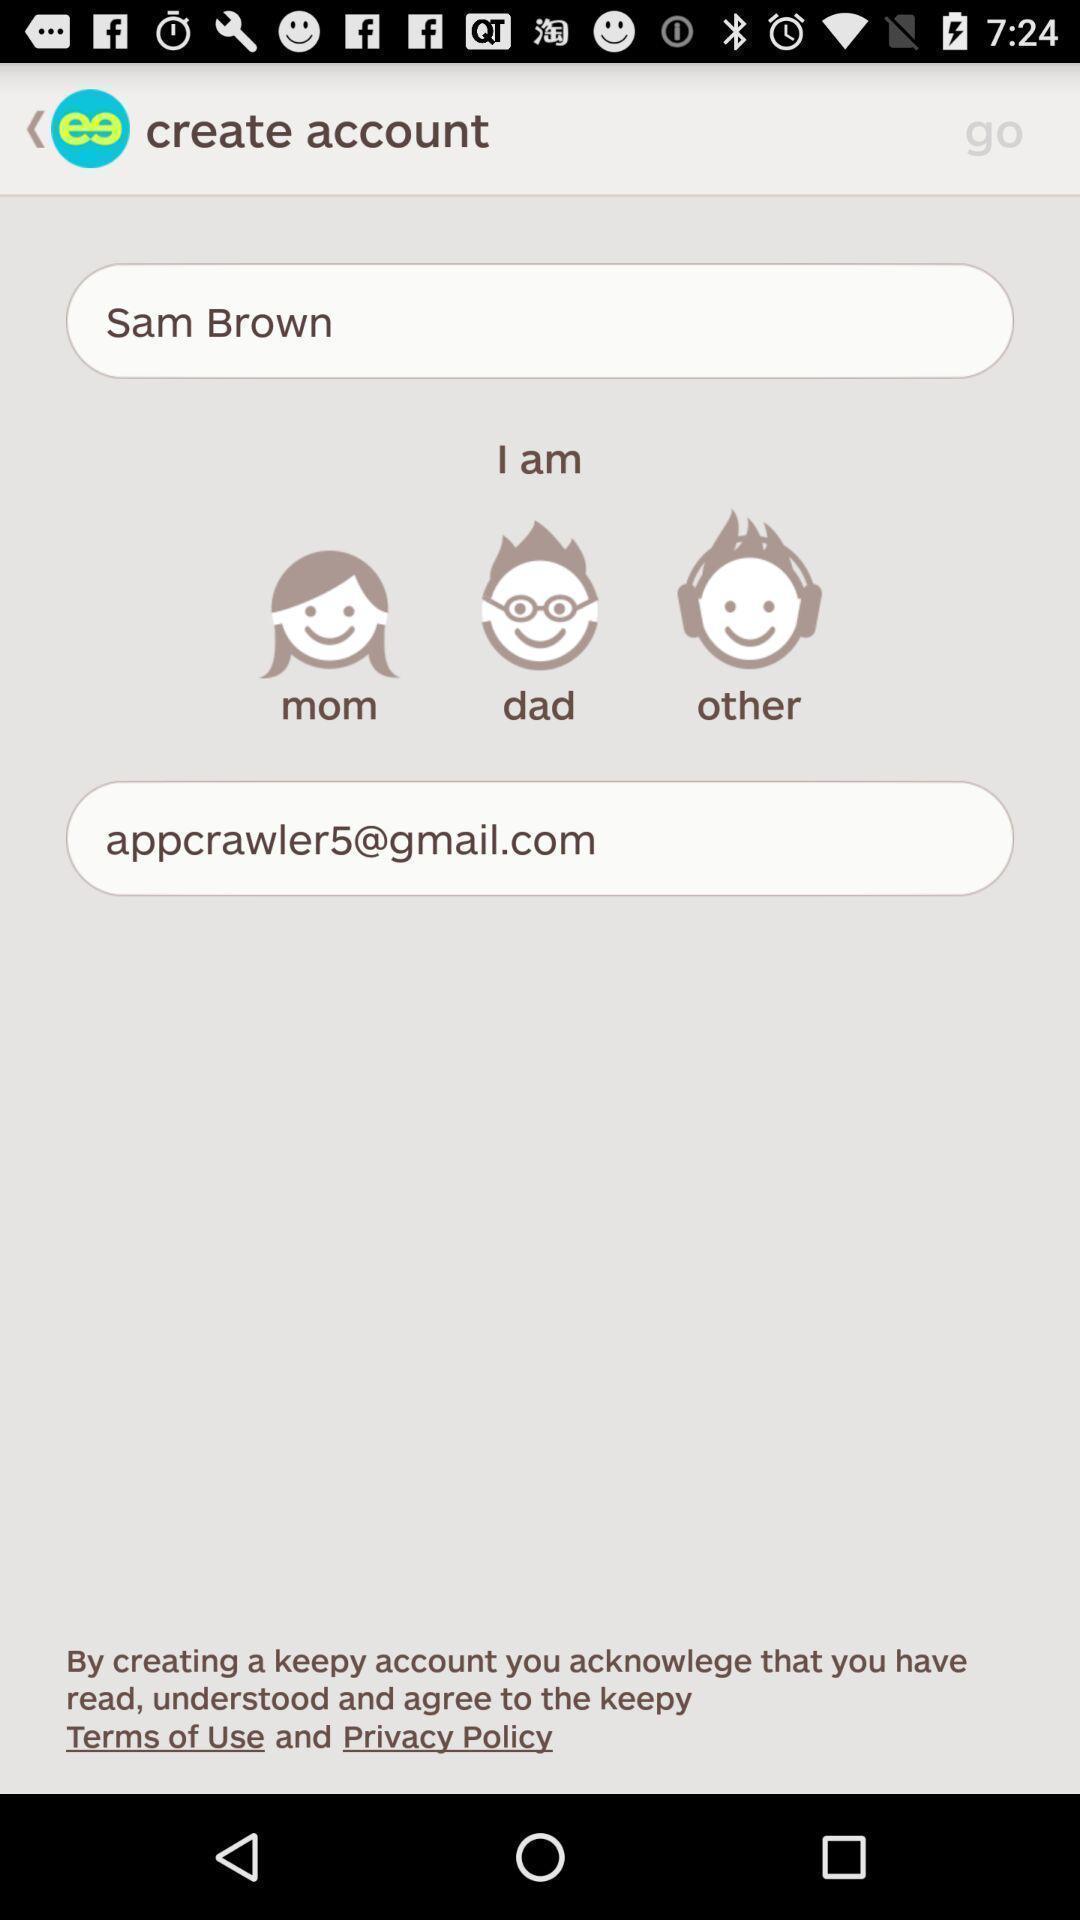Describe the content in this image. Page showing account related options in a kids art app. 